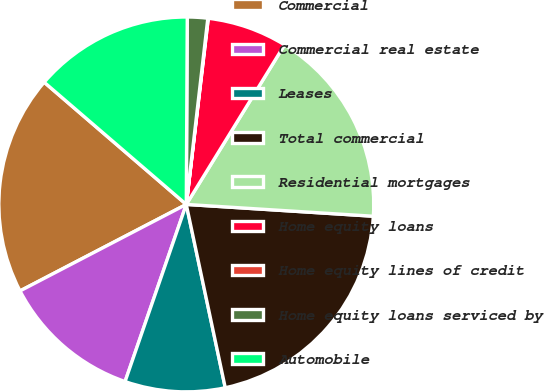Convert chart to OTSL. <chart><loc_0><loc_0><loc_500><loc_500><pie_chart><fcel>Commercial<fcel>Commercial real estate<fcel>Leases<fcel>Total commercial<fcel>Residential mortgages<fcel>Home equity loans<fcel>Home equity lines of credit<fcel>Home equity loans serviced by<fcel>Automobile<nl><fcel>18.94%<fcel>12.07%<fcel>8.63%<fcel>20.66%<fcel>17.22%<fcel>6.91%<fcel>0.04%<fcel>1.75%<fcel>13.78%<nl></chart> 